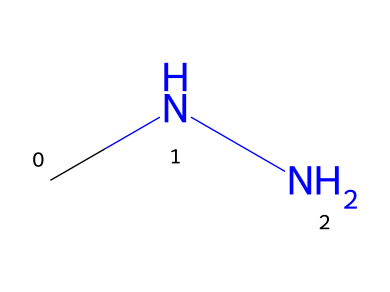How many nitrogen atoms are in this chemical? The SMILES representation "CNN" indicates the presence of two nitrogen atoms, as each "N" corresponds to a nitrogen atom in the structure.
Answer: two What is the chemical name of this structure? The chemical structure represented by "CNN" corresponds to hydrazine, which is the common name for the compound composed of two nitrogen atoms bonded to a central carbon atom.
Answer: hydrazine What type of substance is hydrazine considered? Hydrazine is classified as a hydrazine, which is a compound containing the functional group -N-N- and is typically recognized for its use as a reducing agent and in blowing agents.
Answer: hydrazine Why might hydrazine be used in foam insulation? Hydrazine serves as a blowing agent due to its ability to produce gas upon decomposition, which is essential in creating the foamy structure required for insulation materials.
Answer: blowing agent What type of bonding is present in this chemical structure? The structure contains covalent bonds, which occur between the nitrogen and carbon atoms, indicating that they share electrons to achieve stability.
Answer: covalent What is a common property of hydrazines like this one? A common property of hydrazines is their high reactivity, particularly with oxidizers, which can lead to the release of gases or heat, making them suitable for energy applications.
Answer: high reactivity 